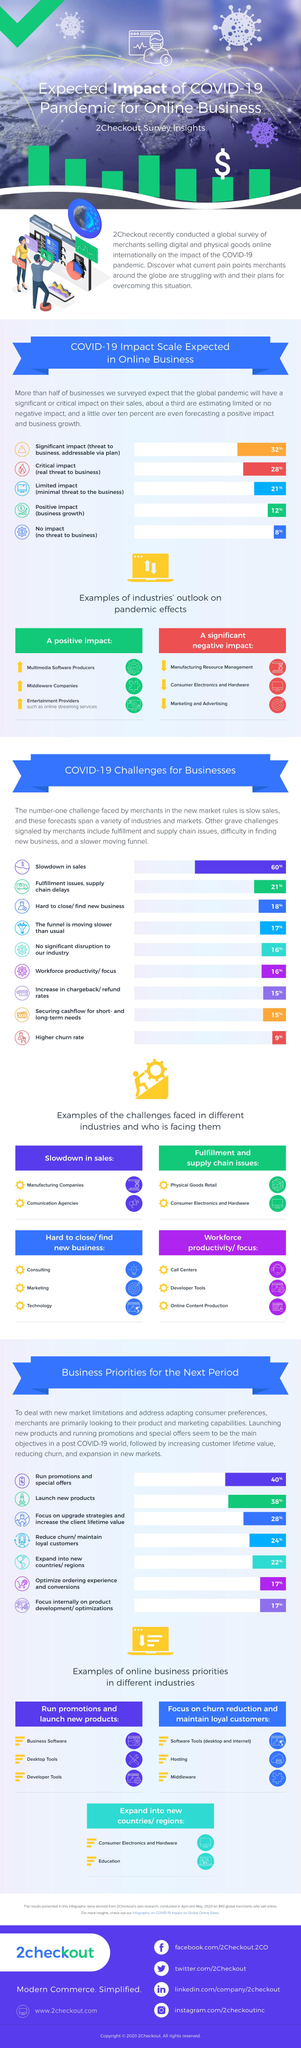Draw attention to some important aspects in this diagram. The second industry that had a positive impact due to the pandemic is middleware companies. Consumer electronics and hardware was the second industry that was significantly impacted by the pandemic, following the travel and tourism industry. The COVID-19 pandemic had a significant and positive impact on online streaming services. The pandemic had a significant negative impact on manufacturing resource management. The physical goods retail industry faced a significant challenge in the form of fulfillment and supply chain issues. 